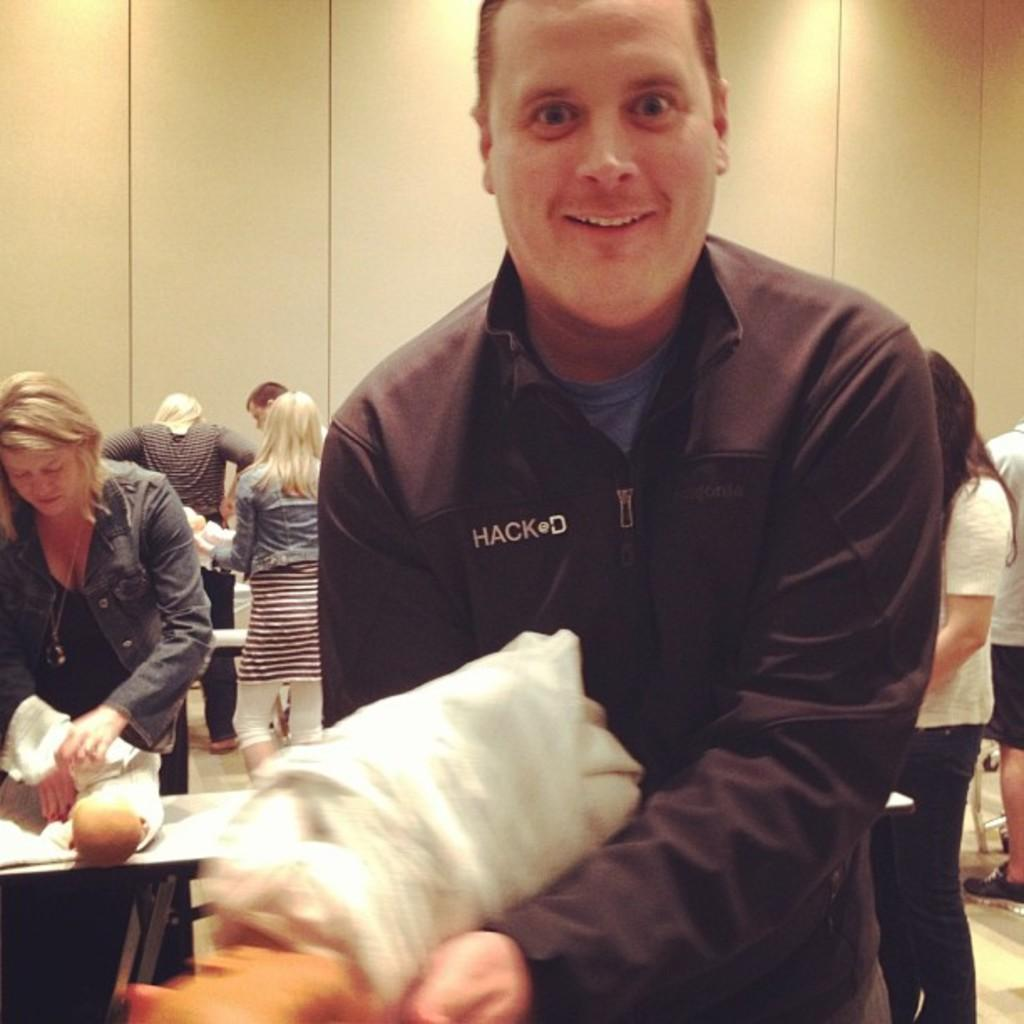What is happening in the foreground of the image? There is a person standing in the foreground of the image. What is the person in the foreground doing? The person is holding something. Can you describe the background of the image? There are other people standing in the background of the image. What type of horn is the person in the foreground playing in the image? There is no horn present in the image; the person is simply holding something. 